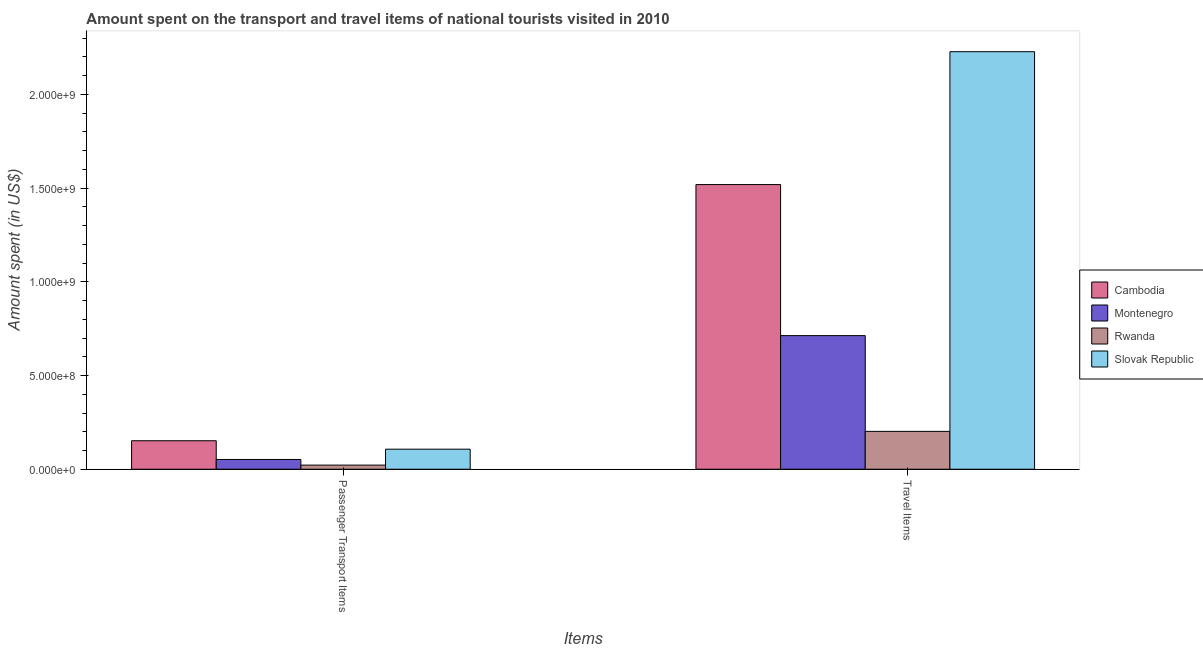How many groups of bars are there?
Ensure brevity in your answer.  2. Are the number of bars on each tick of the X-axis equal?
Your answer should be very brief. Yes. How many bars are there on the 1st tick from the left?
Your answer should be very brief. 4. What is the label of the 2nd group of bars from the left?
Offer a terse response. Travel Items. What is the amount spent on passenger transport items in Rwanda?
Your answer should be very brief. 2.20e+07. Across all countries, what is the maximum amount spent on passenger transport items?
Offer a very short reply. 1.52e+08. Across all countries, what is the minimum amount spent on passenger transport items?
Give a very brief answer. 2.20e+07. In which country was the amount spent on passenger transport items maximum?
Offer a terse response. Cambodia. In which country was the amount spent on passenger transport items minimum?
Offer a terse response. Rwanda. What is the total amount spent on passenger transport items in the graph?
Offer a terse response. 3.33e+08. What is the difference between the amount spent in travel items in Montenegro and that in Rwanda?
Give a very brief answer. 5.11e+08. What is the difference between the amount spent on passenger transport items in Rwanda and the amount spent in travel items in Slovak Republic?
Your answer should be very brief. -2.21e+09. What is the average amount spent in travel items per country?
Give a very brief answer. 1.17e+09. What is the difference between the amount spent on passenger transport items and amount spent in travel items in Montenegro?
Offer a terse response. -6.61e+08. What is the ratio of the amount spent on passenger transport items in Cambodia to that in Montenegro?
Your answer should be very brief. 2.92. In how many countries, is the amount spent in travel items greater than the average amount spent in travel items taken over all countries?
Give a very brief answer. 2. What does the 1st bar from the left in Passenger Transport Items represents?
Give a very brief answer. Cambodia. What does the 3rd bar from the right in Travel Items represents?
Your answer should be very brief. Montenegro. How many bars are there?
Ensure brevity in your answer.  8. Are all the bars in the graph horizontal?
Provide a succinct answer. No. Are the values on the major ticks of Y-axis written in scientific E-notation?
Your response must be concise. Yes. How many legend labels are there?
Your response must be concise. 4. What is the title of the graph?
Offer a terse response. Amount spent on the transport and travel items of national tourists visited in 2010. What is the label or title of the X-axis?
Provide a succinct answer. Items. What is the label or title of the Y-axis?
Provide a short and direct response. Amount spent (in US$). What is the Amount spent (in US$) of Cambodia in Passenger Transport Items?
Provide a succinct answer. 1.52e+08. What is the Amount spent (in US$) of Montenegro in Passenger Transport Items?
Give a very brief answer. 5.20e+07. What is the Amount spent (in US$) of Rwanda in Passenger Transport Items?
Give a very brief answer. 2.20e+07. What is the Amount spent (in US$) of Slovak Republic in Passenger Transport Items?
Your answer should be very brief. 1.07e+08. What is the Amount spent (in US$) of Cambodia in Travel Items?
Offer a very short reply. 1.52e+09. What is the Amount spent (in US$) in Montenegro in Travel Items?
Offer a terse response. 7.13e+08. What is the Amount spent (in US$) in Rwanda in Travel Items?
Ensure brevity in your answer.  2.02e+08. What is the Amount spent (in US$) in Slovak Republic in Travel Items?
Offer a very short reply. 2.23e+09. Across all Items, what is the maximum Amount spent (in US$) in Cambodia?
Your answer should be compact. 1.52e+09. Across all Items, what is the maximum Amount spent (in US$) in Montenegro?
Your response must be concise. 7.13e+08. Across all Items, what is the maximum Amount spent (in US$) of Rwanda?
Offer a terse response. 2.02e+08. Across all Items, what is the maximum Amount spent (in US$) of Slovak Republic?
Your response must be concise. 2.23e+09. Across all Items, what is the minimum Amount spent (in US$) in Cambodia?
Your answer should be compact. 1.52e+08. Across all Items, what is the minimum Amount spent (in US$) in Montenegro?
Make the answer very short. 5.20e+07. Across all Items, what is the minimum Amount spent (in US$) in Rwanda?
Your answer should be very brief. 2.20e+07. Across all Items, what is the minimum Amount spent (in US$) of Slovak Republic?
Your answer should be compact. 1.07e+08. What is the total Amount spent (in US$) of Cambodia in the graph?
Keep it short and to the point. 1.67e+09. What is the total Amount spent (in US$) of Montenegro in the graph?
Make the answer very short. 7.65e+08. What is the total Amount spent (in US$) of Rwanda in the graph?
Your response must be concise. 2.24e+08. What is the total Amount spent (in US$) in Slovak Republic in the graph?
Make the answer very short. 2.34e+09. What is the difference between the Amount spent (in US$) in Cambodia in Passenger Transport Items and that in Travel Items?
Ensure brevity in your answer.  -1.37e+09. What is the difference between the Amount spent (in US$) in Montenegro in Passenger Transport Items and that in Travel Items?
Your response must be concise. -6.61e+08. What is the difference between the Amount spent (in US$) in Rwanda in Passenger Transport Items and that in Travel Items?
Your response must be concise. -1.80e+08. What is the difference between the Amount spent (in US$) in Slovak Republic in Passenger Transport Items and that in Travel Items?
Give a very brief answer. -2.12e+09. What is the difference between the Amount spent (in US$) of Cambodia in Passenger Transport Items and the Amount spent (in US$) of Montenegro in Travel Items?
Provide a short and direct response. -5.61e+08. What is the difference between the Amount spent (in US$) in Cambodia in Passenger Transport Items and the Amount spent (in US$) in Rwanda in Travel Items?
Make the answer very short. -5.00e+07. What is the difference between the Amount spent (in US$) of Cambodia in Passenger Transport Items and the Amount spent (in US$) of Slovak Republic in Travel Items?
Make the answer very short. -2.08e+09. What is the difference between the Amount spent (in US$) in Montenegro in Passenger Transport Items and the Amount spent (in US$) in Rwanda in Travel Items?
Make the answer very short. -1.50e+08. What is the difference between the Amount spent (in US$) of Montenegro in Passenger Transport Items and the Amount spent (in US$) of Slovak Republic in Travel Items?
Ensure brevity in your answer.  -2.18e+09. What is the difference between the Amount spent (in US$) in Rwanda in Passenger Transport Items and the Amount spent (in US$) in Slovak Republic in Travel Items?
Your response must be concise. -2.21e+09. What is the average Amount spent (in US$) of Cambodia per Items?
Offer a terse response. 8.36e+08. What is the average Amount spent (in US$) of Montenegro per Items?
Offer a very short reply. 3.82e+08. What is the average Amount spent (in US$) of Rwanda per Items?
Give a very brief answer. 1.12e+08. What is the average Amount spent (in US$) in Slovak Republic per Items?
Your answer should be compact. 1.17e+09. What is the difference between the Amount spent (in US$) of Cambodia and Amount spent (in US$) of Rwanda in Passenger Transport Items?
Offer a very short reply. 1.30e+08. What is the difference between the Amount spent (in US$) of Cambodia and Amount spent (in US$) of Slovak Republic in Passenger Transport Items?
Keep it short and to the point. 4.50e+07. What is the difference between the Amount spent (in US$) in Montenegro and Amount spent (in US$) in Rwanda in Passenger Transport Items?
Your response must be concise. 3.00e+07. What is the difference between the Amount spent (in US$) of Montenegro and Amount spent (in US$) of Slovak Republic in Passenger Transport Items?
Provide a short and direct response. -5.50e+07. What is the difference between the Amount spent (in US$) of Rwanda and Amount spent (in US$) of Slovak Republic in Passenger Transport Items?
Provide a short and direct response. -8.50e+07. What is the difference between the Amount spent (in US$) in Cambodia and Amount spent (in US$) in Montenegro in Travel Items?
Keep it short and to the point. 8.06e+08. What is the difference between the Amount spent (in US$) of Cambodia and Amount spent (in US$) of Rwanda in Travel Items?
Make the answer very short. 1.32e+09. What is the difference between the Amount spent (in US$) of Cambodia and Amount spent (in US$) of Slovak Republic in Travel Items?
Provide a succinct answer. -7.09e+08. What is the difference between the Amount spent (in US$) of Montenegro and Amount spent (in US$) of Rwanda in Travel Items?
Give a very brief answer. 5.11e+08. What is the difference between the Amount spent (in US$) of Montenegro and Amount spent (in US$) of Slovak Republic in Travel Items?
Your answer should be compact. -1.52e+09. What is the difference between the Amount spent (in US$) in Rwanda and Amount spent (in US$) in Slovak Republic in Travel Items?
Offer a terse response. -2.03e+09. What is the ratio of the Amount spent (in US$) of Cambodia in Passenger Transport Items to that in Travel Items?
Your answer should be compact. 0.1. What is the ratio of the Amount spent (in US$) of Montenegro in Passenger Transport Items to that in Travel Items?
Give a very brief answer. 0.07. What is the ratio of the Amount spent (in US$) of Rwanda in Passenger Transport Items to that in Travel Items?
Keep it short and to the point. 0.11. What is the ratio of the Amount spent (in US$) of Slovak Republic in Passenger Transport Items to that in Travel Items?
Give a very brief answer. 0.05. What is the difference between the highest and the second highest Amount spent (in US$) in Cambodia?
Your answer should be compact. 1.37e+09. What is the difference between the highest and the second highest Amount spent (in US$) in Montenegro?
Offer a terse response. 6.61e+08. What is the difference between the highest and the second highest Amount spent (in US$) in Rwanda?
Make the answer very short. 1.80e+08. What is the difference between the highest and the second highest Amount spent (in US$) of Slovak Republic?
Offer a terse response. 2.12e+09. What is the difference between the highest and the lowest Amount spent (in US$) in Cambodia?
Offer a terse response. 1.37e+09. What is the difference between the highest and the lowest Amount spent (in US$) in Montenegro?
Provide a succinct answer. 6.61e+08. What is the difference between the highest and the lowest Amount spent (in US$) in Rwanda?
Ensure brevity in your answer.  1.80e+08. What is the difference between the highest and the lowest Amount spent (in US$) in Slovak Republic?
Your response must be concise. 2.12e+09. 